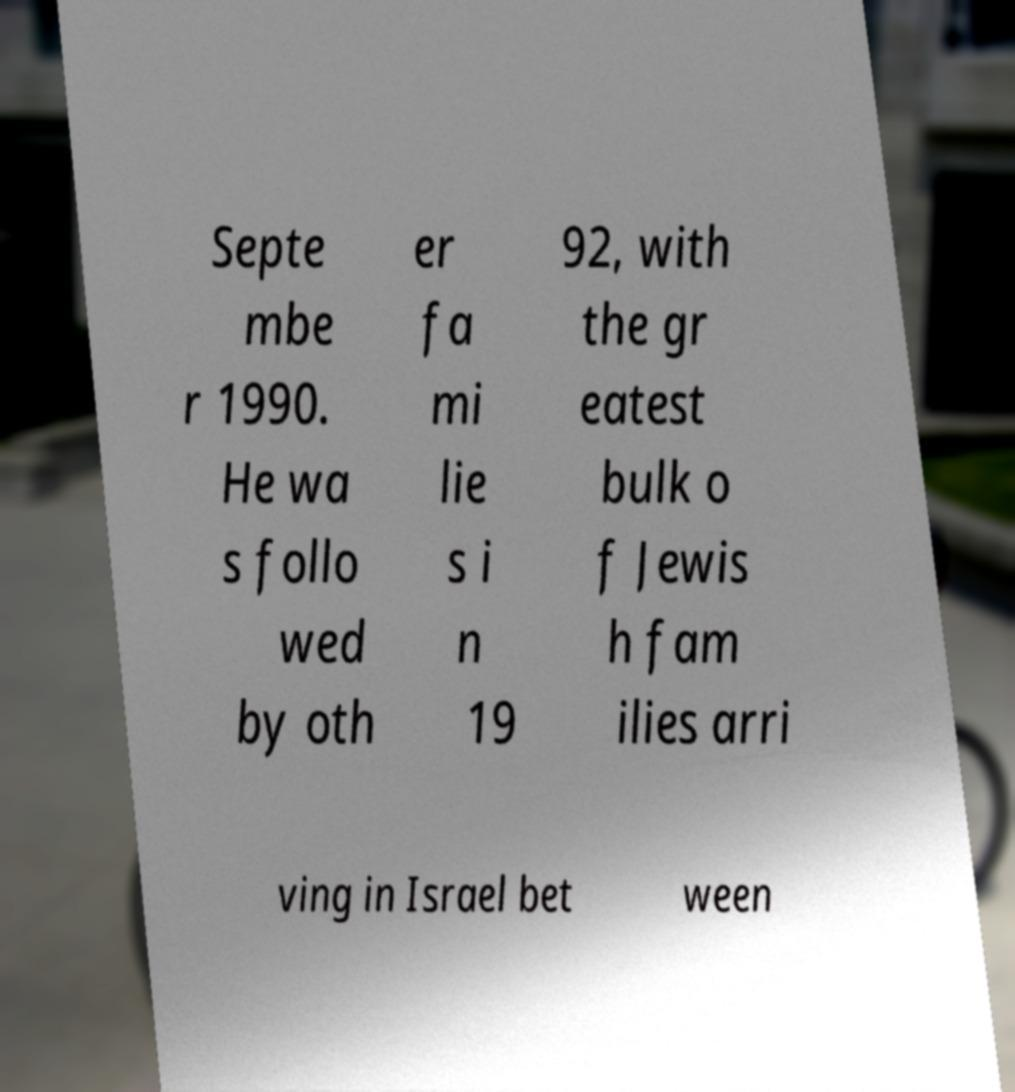There's text embedded in this image that I need extracted. Can you transcribe it verbatim? Septe mbe r 1990. He wa s follo wed by oth er fa mi lie s i n 19 92, with the gr eatest bulk o f Jewis h fam ilies arri ving in Israel bet ween 